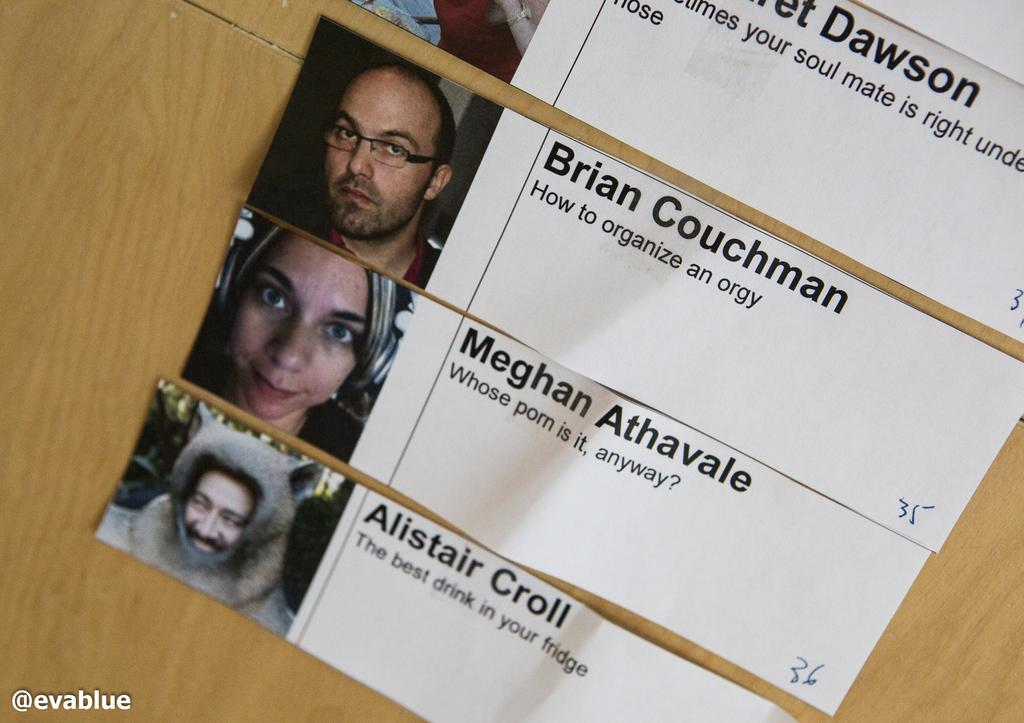What is the color of the wooden surface in the image? The wooden surface in the image is cream and brown colored. What is attached to the wooden surface? There are papers attached to the wooden surface. What can be seen on the papers? The papers contain pictures of persons. Is there any text on the papers? Yes, there is writing on the papers. What type of house is visible in the background of the image? There is no house visible in the background of the image. Is there a band playing music in the image? There is no band playing music in the image. 